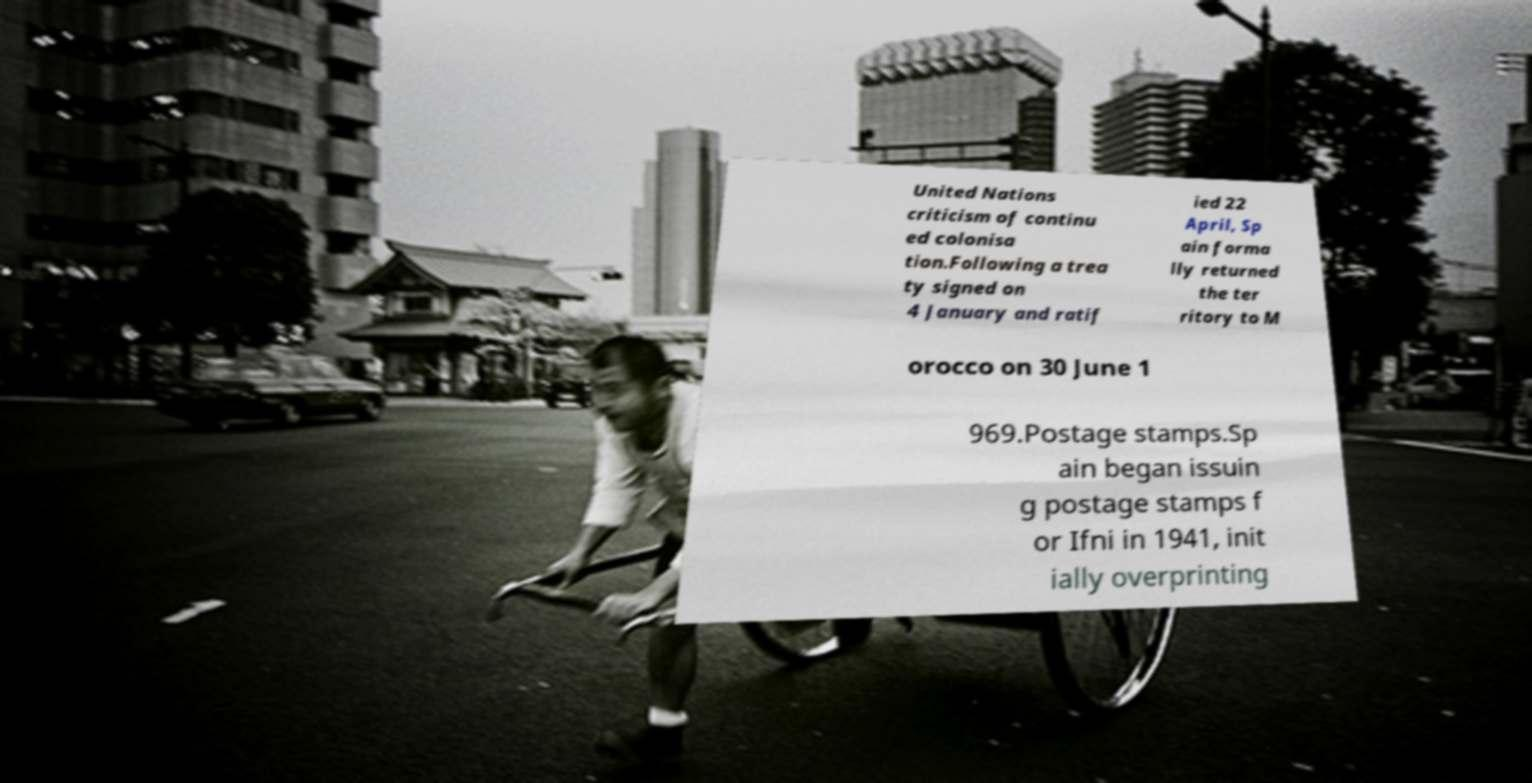Please read and relay the text visible in this image. What does it say? United Nations criticism of continu ed colonisa tion.Following a trea ty signed on 4 January and ratif ied 22 April, Sp ain forma lly returned the ter ritory to M orocco on 30 June 1 969.Postage stamps.Sp ain began issuin g postage stamps f or Ifni in 1941, init ially overprinting 